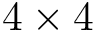Convert formula to latex. <formula><loc_0><loc_0><loc_500><loc_500>4 \times 4</formula> 